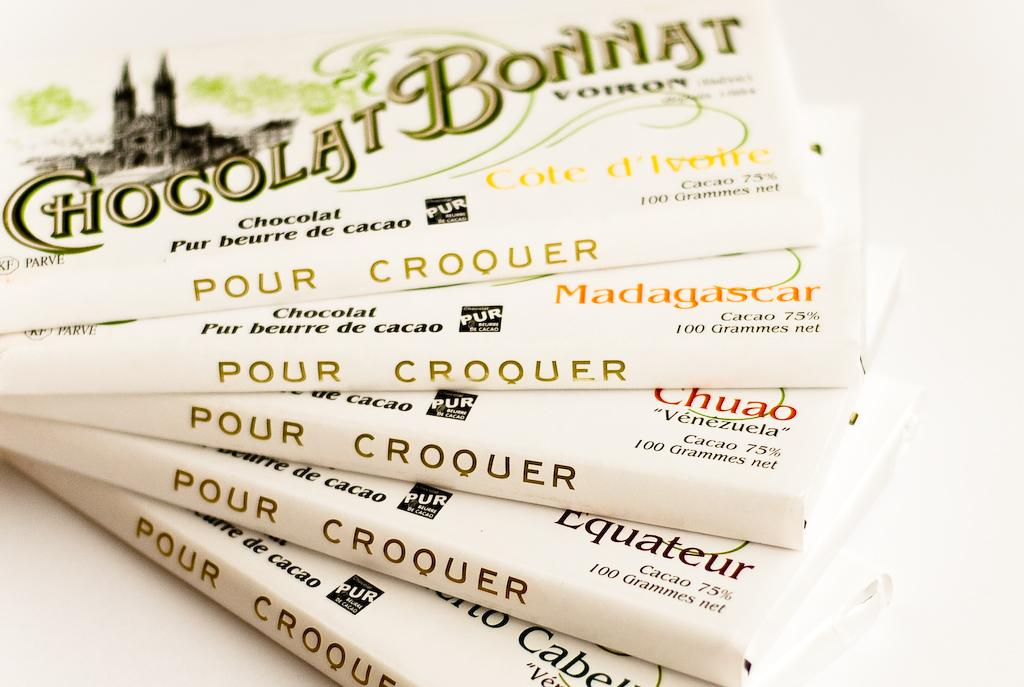What objects can be seen arranged on a surface in the image? There are books arranged on a surface in the image. What color is the background of the image? The background of the image is white. Reasoning: Let' Let's think step by step in order to produce the conversation. We start by identifying the main subject in the image, which is the books arranged on a surface. Then, we expand the conversation to include the background color, which is white. Each question is designed to elicit a specific detail about the image that is known from the provided facts. Absurd Question/Answer: What type of marble is visible on the books in the image? There is no marble present on the books in the image. What attempt is being made by the books in the image? The books are not making any attempt; they are simply arranged on a surface. 